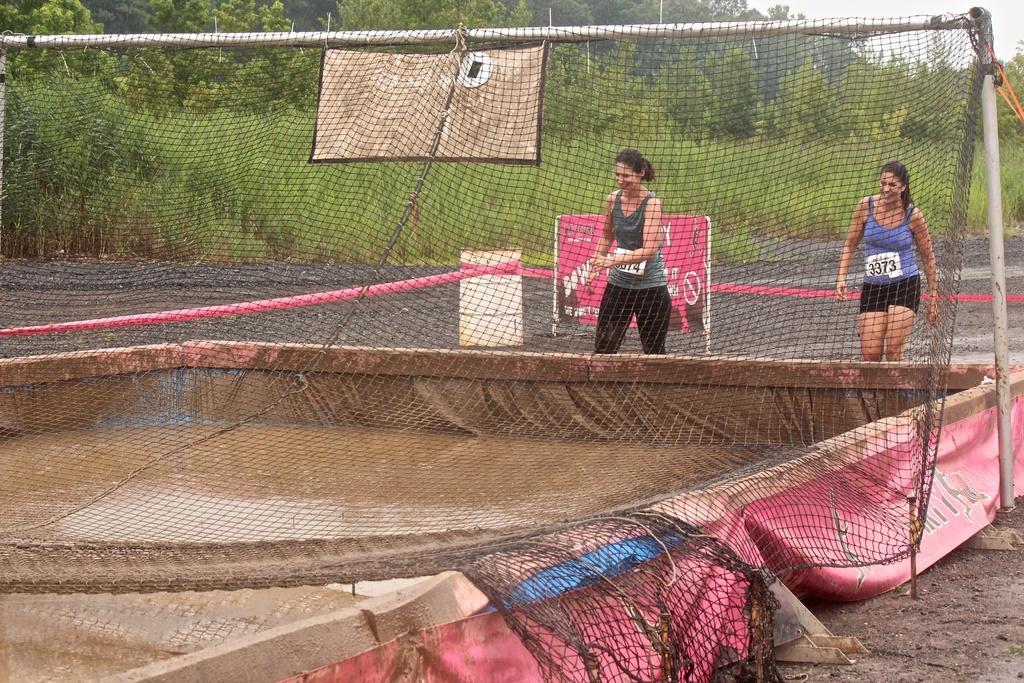Describe this image in one or two sentences. In this image there are ladies and we can see a net. There is water. In the background we can see trees and there is sky. 